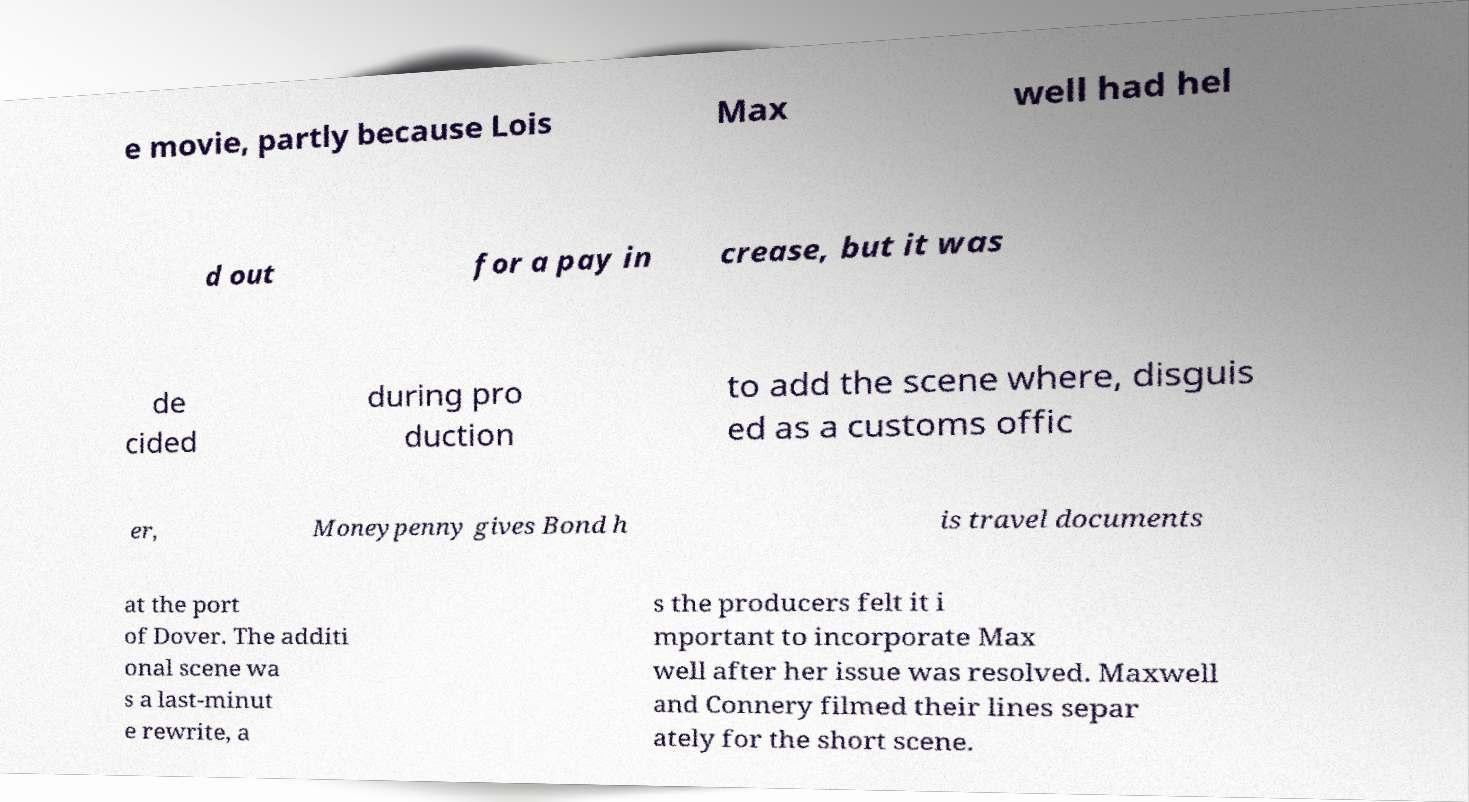For documentation purposes, I need the text within this image transcribed. Could you provide that? e movie, partly because Lois Max well had hel d out for a pay in crease, but it was de cided during pro duction to add the scene where, disguis ed as a customs offic er, Moneypenny gives Bond h is travel documents at the port of Dover. The additi onal scene wa s a last-minut e rewrite, a s the producers felt it i mportant to incorporate Max well after her issue was resolved. Maxwell and Connery filmed their lines separ ately for the short scene. 